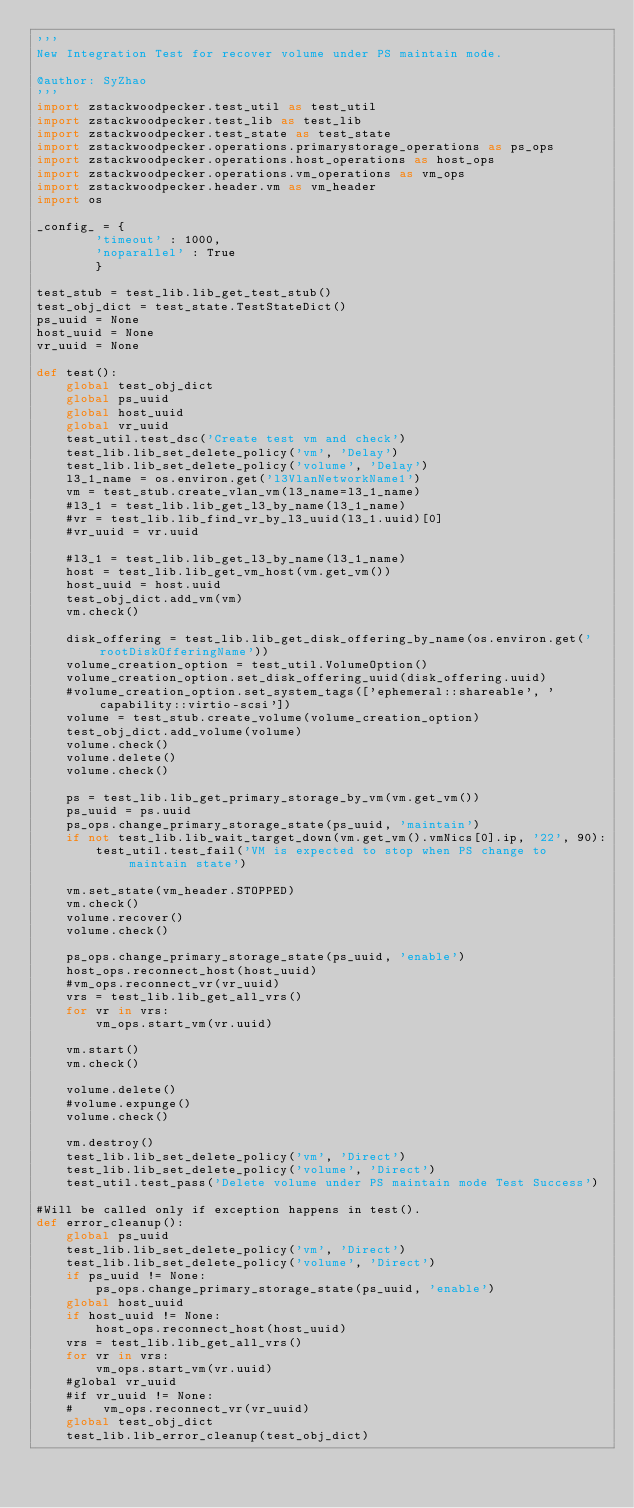Convert code to text. <code><loc_0><loc_0><loc_500><loc_500><_Python_>'''
New Integration Test for recover volume under PS maintain mode.

@author: SyZhao
'''
import zstackwoodpecker.test_util as test_util
import zstackwoodpecker.test_lib as test_lib
import zstackwoodpecker.test_state as test_state
import zstackwoodpecker.operations.primarystorage_operations as ps_ops
import zstackwoodpecker.operations.host_operations as host_ops
import zstackwoodpecker.operations.vm_operations as vm_ops
import zstackwoodpecker.header.vm as vm_header
import os

_config_ = {
        'timeout' : 1000,
        'noparallel' : True
        }

test_stub = test_lib.lib_get_test_stub()
test_obj_dict = test_state.TestStateDict()
ps_uuid = None
host_uuid = None
vr_uuid = None

def test():
    global test_obj_dict
    global ps_uuid
    global host_uuid
    global vr_uuid
    test_util.test_dsc('Create test vm and check')
    test_lib.lib_set_delete_policy('vm', 'Delay')
    test_lib.lib_set_delete_policy('volume', 'Delay')
    l3_1_name = os.environ.get('l3VlanNetworkName1')
    vm = test_stub.create_vlan_vm(l3_name=l3_1_name)
    #l3_1 = test_lib.lib_get_l3_by_name(l3_1_name)
    #vr = test_lib.lib_find_vr_by_l3_uuid(l3_1.uuid)[0]
    #vr_uuid = vr.uuid
    
    #l3_1 = test_lib.lib_get_l3_by_name(l3_1_name)
    host = test_lib.lib_get_vm_host(vm.get_vm())
    host_uuid = host.uuid
    test_obj_dict.add_vm(vm)
    vm.check()

    disk_offering = test_lib.lib_get_disk_offering_by_name(os.environ.get('rootDiskOfferingName'))
    volume_creation_option = test_util.VolumeOption()
    volume_creation_option.set_disk_offering_uuid(disk_offering.uuid)
    #volume_creation_option.set_system_tags(['ephemeral::shareable', 'capability::virtio-scsi'])
    volume = test_stub.create_volume(volume_creation_option)
    test_obj_dict.add_volume(volume)
    volume.check()
    volume.delete()
    volume.check()

    ps = test_lib.lib_get_primary_storage_by_vm(vm.get_vm())
    ps_uuid = ps.uuid
    ps_ops.change_primary_storage_state(ps_uuid, 'maintain')
    if not test_lib.lib_wait_target_down(vm.get_vm().vmNics[0].ip, '22', 90):
        test_util.test_fail('VM is expected to stop when PS change to maintain state')

    vm.set_state(vm_header.STOPPED)
    vm.check()
    volume.recover()
    volume.check()

    ps_ops.change_primary_storage_state(ps_uuid, 'enable')
    host_ops.reconnect_host(host_uuid)
    #vm_ops.reconnect_vr(vr_uuid)
    vrs = test_lib.lib_get_all_vrs()
    for vr in vrs:
        vm_ops.start_vm(vr.uuid)  

    vm.start()
    vm.check()

    volume.delete()
    #volume.expunge()
    volume.check()

    vm.destroy()
    test_lib.lib_set_delete_policy('vm', 'Direct')
    test_lib.lib_set_delete_policy('volume', 'Direct')
    test_util.test_pass('Delete volume under PS maintain mode Test Success')

#Will be called only if exception happens in test().
def error_cleanup():
    global ps_uuid
    test_lib.lib_set_delete_policy('vm', 'Direct')
    test_lib.lib_set_delete_policy('volume', 'Direct')
    if ps_uuid != None:
        ps_ops.change_primary_storage_state(ps_uuid, 'enable')
    global host_uuid
    if host_uuid != None:
        host_ops.reconnect_host(host_uuid)
    vrs = test_lib.lib_get_all_vrs()
    for vr in vrs:
        vm_ops.start_vm(vr.uuid)  
    #global vr_uuid
    #if vr_uuid != None:
    #    vm_ops.reconnect_vr(vr_uuid)
    global test_obj_dict
    test_lib.lib_error_cleanup(test_obj_dict)
</code> 